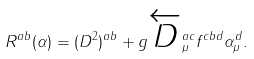<formula> <loc_0><loc_0><loc_500><loc_500>R ^ { a b } ( \alpha ) = ( D ^ { 2 } ) ^ { a b } + g \overleftarrow { D } _ { \mu } ^ { a c } f ^ { c b d } \alpha _ { \mu } ^ { d } .</formula> 